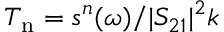Convert formula to latex. <formula><loc_0><loc_0><loc_500><loc_500>T _ { n } = s ^ { n } ( \omega ) / | S _ { 2 1 } | ^ { 2 } k</formula> 